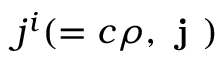<formula> <loc_0><loc_0><loc_500><loc_500>j ^ { i } ( = c \rho , j )</formula> 